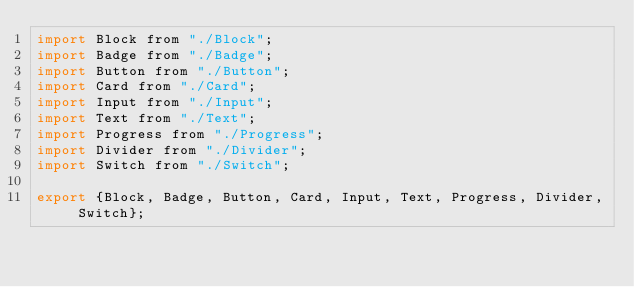<code> <loc_0><loc_0><loc_500><loc_500><_JavaScript_>import Block from "./Block";
import Badge from "./Badge";
import Button from "./Button";
import Card from "./Card";
import Input from "./Input";
import Text from "./Text";
import Progress from "./Progress";
import Divider from "./Divider";
import Switch from "./Switch";

export {Block, Badge, Button, Card, Input, Text, Progress, Divider, Switch};</code> 